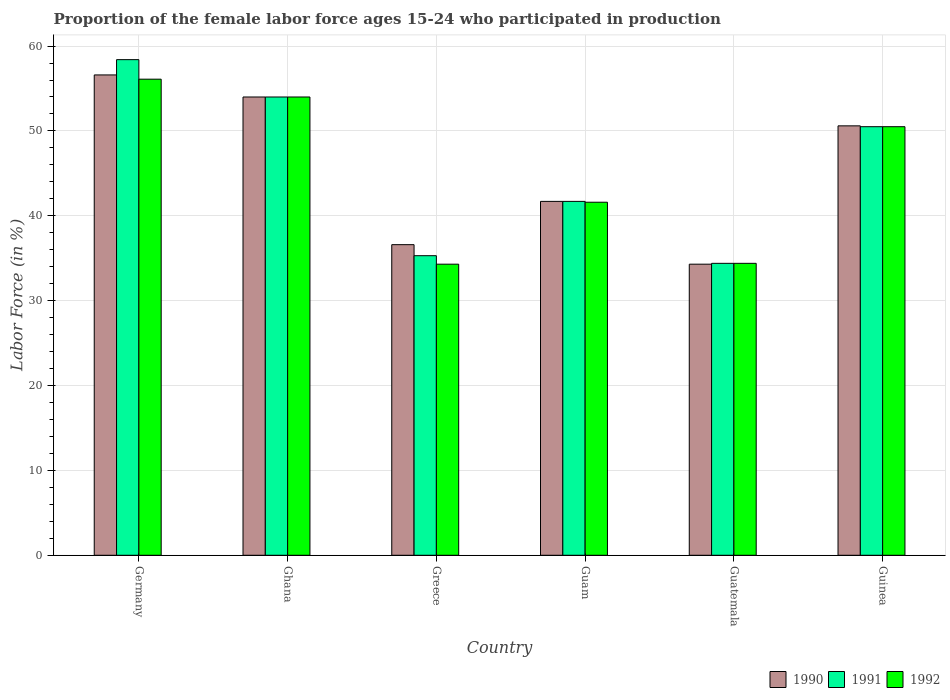Are the number of bars on each tick of the X-axis equal?
Your response must be concise. Yes. How many bars are there on the 6th tick from the right?
Your answer should be very brief. 3. In how many cases, is the number of bars for a given country not equal to the number of legend labels?
Your answer should be very brief. 0. What is the proportion of the female labor force who participated in production in 1990 in Germany?
Offer a very short reply. 56.6. Across all countries, what is the maximum proportion of the female labor force who participated in production in 1990?
Your answer should be compact. 56.6. Across all countries, what is the minimum proportion of the female labor force who participated in production in 1991?
Your response must be concise. 34.4. In which country was the proportion of the female labor force who participated in production in 1992 maximum?
Provide a short and direct response. Germany. In which country was the proportion of the female labor force who participated in production in 1992 minimum?
Your response must be concise. Greece. What is the total proportion of the female labor force who participated in production in 1990 in the graph?
Offer a terse response. 273.8. What is the difference between the proportion of the female labor force who participated in production in 1991 in Germany and that in Guam?
Your answer should be very brief. 16.7. What is the difference between the proportion of the female labor force who participated in production in 1990 in Greece and the proportion of the female labor force who participated in production in 1991 in Guinea?
Offer a very short reply. -13.9. What is the average proportion of the female labor force who participated in production in 1990 per country?
Offer a terse response. 45.63. What is the difference between the proportion of the female labor force who participated in production of/in 1991 and proportion of the female labor force who participated in production of/in 1990 in Guatemala?
Ensure brevity in your answer.  0.1. What is the ratio of the proportion of the female labor force who participated in production in 1992 in Ghana to that in Guinea?
Give a very brief answer. 1.07. Is the proportion of the female labor force who participated in production in 1991 in Ghana less than that in Greece?
Your response must be concise. No. Is the difference between the proportion of the female labor force who participated in production in 1991 in Guam and Guatemala greater than the difference between the proportion of the female labor force who participated in production in 1990 in Guam and Guatemala?
Your answer should be very brief. No. What is the difference between the highest and the second highest proportion of the female labor force who participated in production in 1991?
Offer a terse response. 7.9. What is the difference between the highest and the lowest proportion of the female labor force who participated in production in 1991?
Provide a short and direct response. 24. In how many countries, is the proportion of the female labor force who participated in production in 1990 greater than the average proportion of the female labor force who participated in production in 1990 taken over all countries?
Make the answer very short. 3. Is the sum of the proportion of the female labor force who participated in production in 1990 in Germany and Greece greater than the maximum proportion of the female labor force who participated in production in 1992 across all countries?
Your answer should be compact. Yes. What does the 2nd bar from the right in Guinea represents?
Your answer should be very brief. 1991. What is the difference between two consecutive major ticks on the Y-axis?
Provide a short and direct response. 10. Does the graph contain grids?
Ensure brevity in your answer.  Yes. How many legend labels are there?
Provide a short and direct response. 3. How are the legend labels stacked?
Offer a very short reply. Horizontal. What is the title of the graph?
Provide a short and direct response. Proportion of the female labor force ages 15-24 who participated in production. What is the label or title of the Y-axis?
Offer a very short reply. Labor Force (in %). What is the Labor Force (in %) of 1990 in Germany?
Provide a succinct answer. 56.6. What is the Labor Force (in %) of 1991 in Germany?
Provide a short and direct response. 58.4. What is the Labor Force (in %) in 1992 in Germany?
Provide a succinct answer. 56.1. What is the Labor Force (in %) of 1990 in Ghana?
Your answer should be compact. 54. What is the Labor Force (in %) in 1991 in Ghana?
Give a very brief answer. 54. What is the Labor Force (in %) in 1990 in Greece?
Your answer should be compact. 36.6. What is the Labor Force (in %) of 1991 in Greece?
Offer a terse response. 35.3. What is the Labor Force (in %) of 1992 in Greece?
Provide a short and direct response. 34.3. What is the Labor Force (in %) of 1990 in Guam?
Provide a succinct answer. 41.7. What is the Labor Force (in %) of 1991 in Guam?
Your answer should be compact. 41.7. What is the Labor Force (in %) of 1992 in Guam?
Your response must be concise. 41.6. What is the Labor Force (in %) in 1990 in Guatemala?
Offer a very short reply. 34.3. What is the Labor Force (in %) in 1991 in Guatemala?
Offer a terse response. 34.4. What is the Labor Force (in %) of 1992 in Guatemala?
Make the answer very short. 34.4. What is the Labor Force (in %) of 1990 in Guinea?
Make the answer very short. 50.6. What is the Labor Force (in %) in 1991 in Guinea?
Provide a succinct answer. 50.5. What is the Labor Force (in %) of 1992 in Guinea?
Provide a succinct answer. 50.5. Across all countries, what is the maximum Labor Force (in %) of 1990?
Provide a succinct answer. 56.6. Across all countries, what is the maximum Labor Force (in %) in 1991?
Give a very brief answer. 58.4. Across all countries, what is the maximum Labor Force (in %) of 1992?
Your answer should be very brief. 56.1. Across all countries, what is the minimum Labor Force (in %) of 1990?
Ensure brevity in your answer.  34.3. Across all countries, what is the minimum Labor Force (in %) of 1991?
Offer a very short reply. 34.4. Across all countries, what is the minimum Labor Force (in %) of 1992?
Offer a very short reply. 34.3. What is the total Labor Force (in %) of 1990 in the graph?
Provide a succinct answer. 273.8. What is the total Labor Force (in %) of 1991 in the graph?
Ensure brevity in your answer.  274.3. What is the total Labor Force (in %) of 1992 in the graph?
Make the answer very short. 270.9. What is the difference between the Labor Force (in %) in 1990 in Germany and that in Ghana?
Your response must be concise. 2.6. What is the difference between the Labor Force (in %) of 1992 in Germany and that in Ghana?
Keep it short and to the point. 2.1. What is the difference between the Labor Force (in %) of 1990 in Germany and that in Greece?
Your answer should be very brief. 20. What is the difference between the Labor Force (in %) of 1991 in Germany and that in Greece?
Provide a succinct answer. 23.1. What is the difference between the Labor Force (in %) of 1992 in Germany and that in Greece?
Provide a short and direct response. 21.8. What is the difference between the Labor Force (in %) in 1990 in Germany and that in Guam?
Your answer should be very brief. 14.9. What is the difference between the Labor Force (in %) of 1992 in Germany and that in Guam?
Keep it short and to the point. 14.5. What is the difference between the Labor Force (in %) of 1990 in Germany and that in Guatemala?
Make the answer very short. 22.3. What is the difference between the Labor Force (in %) in 1992 in Germany and that in Guatemala?
Your response must be concise. 21.7. What is the difference between the Labor Force (in %) in 1990 in Germany and that in Guinea?
Make the answer very short. 6. What is the difference between the Labor Force (in %) of 1990 in Ghana and that in Greece?
Make the answer very short. 17.4. What is the difference between the Labor Force (in %) in 1991 in Ghana and that in Greece?
Ensure brevity in your answer.  18.7. What is the difference between the Labor Force (in %) of 1990 in Ghana and that in Guam?
Offer a terse response. 12.3. What is the difference between the Labor Force (in %) of 1991 in Ghana and that in Guam?
Ensure brevity in your answer.  12.3. What is the difference between the Labor Force (in %) of 1990 in Ghana and that in Guatemala?
Give a very brief answer. 19.7. What is the difference between the Labor Force (in %) of 1991 in Ghana and that in Guatemala?
Ensure brevity in your answer.  19.6. What is the difference between the Labor Force (in %) of 1992 in Ghana and that in Guatemala?
Give a very brief answer. 19.6. What is the difference between the Labor Force (in %) of 1990 in Ghana and that in Guinea?
Provide a short and direct response. 3.4. What is the difference between the Labor Force (in %) in 1991 in Ghana and that in Guinea?
Provide a succinct answer. 3.5. What is the difference between the Labor Force (in %) in 1992 in Ghana and that in Guinea?
Your response must be concise. 3.5. What is the difference between the Labor Force (in %) of 1990 in Greece and that in Guam?
Keep it short and to the point. -5.1. What is the difference between the Labor Force (in %) in 1990 in Greece and that in Guatemala?
Your answer should be very brief. 2.3. What is the difference between the Labor Force (in %) of 1991 in Greece and that in Guatemala?
Ensure brevity in your answer.  0.9. What is the difference between the Labor Force (in %) of 1990 in Greece and that in Guinea?
Give a very brief answer. -14. What is the difference between the Labor Force (in %) in 1991 in Greece and that in Guinea?
Offer a very short reply. -15.2. What is the difference between the Labor Force (in %) in 1992 in Greece and that in Guinea?
Give a very brief answer. -16.2. What is the difference between the Labor Force (in %) in 1991 in Guam and that in Guatemala?
Provide a short and direct response. 7.3. What is the difference between the Labor Force (in %) in 1992 in Guam and that in Guatemala?
Your answer should be compact. 7.2. What is the difference between the Labor Force (in %) of 1990 in Guam and that in Guinea?
Keep it short and to the point. -8.9. What is the difference between the Labor Force (in %) of 1991 in Guam and that in Guinea?
Your response must be concise. -8.8. What is the difference between the Labor Force (in %) in 1992 in Guam and that in Guinea?
Give a very brief answer. -8.9. What is the difference between the Labor Force (in %) in 1990 in Guatemala and that in Guinea?
Ensure brevity in your answer.  -16.3. What is the difference between the Labor Force (in %) of 1991 in Guatemala and that in Guinea?
Keep it short and to the point. -16.1. What is the difference between the Labor Force (in %) of 1992 in Guatemala and that in Guinea?
Keep it short and to the point. -16.1. What is the difference between the Labor Force (in %) of 1990 in Germany and the Labor Force (in %) of 1991 in Ghana?
Keep it short and to the point. 2.6. What is the difference between the Labor Force (in %) of 1990 in Germany and the Labor Force (in %) of 1992 in Ghana?
Offer a terse response. 2.6. What is the difference between the Labor Force (in %) of 1990 in Germany and the Labor Force (in %) of 1991 in Greece?
Offer a terse response. 21.3. What is the difference between the Labor Force (in %) of 1990 in Germany and the Labor Force (in %) of 1992 in Greece?
Make the answer very short. 22.3. What is the difference between the Labor Force (in %) of 1991 in Germany and the Labor Force (in %) of 1992 in Greece?
Your response must be concise. 24.1. What is the difference between the Labor Force (in %) in 1990 in Germany and the Labor Force (in %) in 1991 in Guam?
Your answer should be very brief. 14.9. What is the difference between the Labor Force (in %) of 1991 in Germany and the Labor Force (in %) of 1992 in Guam?
Make the answer very short. 16.8. What is the difference between the Labor Force (in %) of 1991 in Germany and the Labor Force (in %) of 1992 in Guatemala?
Keep it short and to the point. 24. What is the difference between the Labor Force (in %) of 1990 in Germany and the Labor Force (in %) of 1992 in Guinea?
Offer a terse response. 6.1. What is the difference between the Labor Force (in %) in 1991 in Ghana and the Labor Force (in %) in 1992 in Guam?
Offer a terse response. 12.4. What is the difference between the Labor Force (in %) in 1990 in Ghana and the Labor Force (in %) in 1991 in Guatemala?
Provide a succinct answer. 19.6. What is the difference between the Labor Force (in %) in 1990 in Ghana and the Labor Force (in %) in 1992 in Guatemala?
Ensure brevity in your answer.  19.6. What is the difference between the Labor Force (in %) in 1991 in Ghana and the Labor Force (in %) in 1992 in Guatemala?
Your response must be concise. 19.6. What is the difference between the Labor Force (in %) in 1990 in Ghana and the Labor Force (in %) in 1991 in Guinea?
Your answer should be compact. 3.5. What is the difference between the Labor Force (in %) in 1990 in Ghana and the Labor Force (in %) in 1992 in Guinea?
Provide a succinct answer. 3.5. What is the difference between the Labor Force (in %) in 1991 in Ghana and the Labor Force (in %) in 1992 in Guinea?
Your answer should be very brief. 3.5. What is the difference between the Labor Force (in %) in 1990 in Greece and the Labor Force (in %) in 1991 in Guam?
Provide a succinct answer. -5.1. What is the difference between the Labor Force (in %) in 1990 in Greece and the Labor Force (in %) in 1992 in Guam?
Your answer should be very brief. -5. What is the difference between the Labor Force (in %) in 1990 in Greece and the Labor Force (in %) in 1991 in Guatemala?
Your answer should be compact. 2.2. What is the difference between the Labor Force (in %) in 1991 in Greece and the Labor Force (in %) in 1992 in Guatemala?
Keep it short and to the point. 0.9. What is the difference between the Labor Force (in %) of 1991 in Greece and the Labor Force (in %) of 1992 in Guinea?
Keep it short and to the point. -15.2. What is the difference between the Labor Force (in %) of 1990 in Guam and the Labor Force (in %) of 1992 in Guatemala?
Provide a short and direct response. 7.3. What is the difference between the Labor Force (in %) in 1991 in Guam and the Labor Force (in %) in 1992 in Guatemala?
Offer a very short reply. 7.3. What is the difference between the Labor Force (in %) in 1990 in Guatemala and the Labor Force (in %) in 1991 in Guinea?
Your response must be concise. -16.2. What is the difference between the Labor Force (in %) in 1990 in Guatemala and the Labor Force (in %) in 1992 in Guinea?
Provide a short and direct response. -16.2. What is the difference between the Labor Force (in %) of 1991 in Guatemala and the Labor Force (in %) of 1992 in Guinea?
Keep it short and to the point. -16.1. What is the average Labor Force (in %) of 1990 per country?
Your response must be concise. 45.63. What is the average Labor Force (in %) of 1991 per country?
Offer a terse response. 45.72. What is the average Labor Force (in %) of 1992 per country?
Ensure brevity in your answer.  45.15. What is the difference between the Labor Force (in %) of 1990 and Labor Force (in %) of 1991 in Germany?
Ensure brevity in your answer.  -1.8. What is the difference between the Labor Force (in %) of 1990 and Labor Force (in %) of 1992 in Germany?
Your response must be concise. 0.5. What is the difference between the Labor Force (in %) in 1990 and Labor Force (in %) in 1992 in Ghana?
Provide a short and direct response. 0. What is the difference between the Labor Force (in %) in 1991 and Labor Force (in %) in 1992 in Ghana?
Your answer should be compact. 0. What is the difference between the Labor Force (in %) in 1990 and Labor Force (in %) in 1991 in Greece?
Keep it short and to the point. 1.3. What is the difference between the Labor Force (in %) in 1990 and Labor Force (in %) in 1992 in Greece?
Provide a succinct answer. 2.3. What is the difference between the Labor Force (in %) of 1990 and Labor Force (in %) of 1991 in Guam?
Your response must be concise. 0. What is the difference between the Labor Force (in %) in 1990 and Labor Force (in %) in 1991 in Guatemala?
Offer a terse response. -0.1. What is the difference between the Labor Force (in %) in 1990 and Labor Force (in %) in 1992 in Guatemala?
Give a very brief answer. -0.1. What is the difference between the Labor Force (in %) in 1991 and Labor Force (in %) in 1992 in Guatemala?
Your answer should be very brief. 0. What is the ratio of the Labor Force (in %) of 1990 in Germany to that in Ghana?
Your response must be concise. 1.05. What is the ratio of the Labor Force (in %) in 1991 in Germany to that in Ghana?
Your response must be concise. 1.08. What is the ratio of the Labor Force (in %) in 1992 in Germany to that in Ghana?
Ensure brevity in your answer.  1.04. What is the ratio of the Labor Force (in %) in 1990 in Germany to that in Greece?
Give a very brief answer. 1.55. What is the ratio of the Labor Force (in %) in 1991 in Germany to that in Greece?
Keep it short and to the point. 1.65. What is the ratio of the Labor Force (in %) in 1992 in Germany to that in Greece?
Offer a terse response. 1.64. What is the ratio of the Labor Force (in %) in 1990 in Germany to that in Guam?
Give a very brief answer. 1.36. What is the ratio of the Labor Force (in %) in 1991 in Germany to that in Guam?
Provide a succinct answer. 1.4. What is the ratio of the Labor Force (in %) of 1992 in Germany to that in Guam?
Offer a terse response. 1.35. What is the ratio of the Labor Force (in %) in 1990 in Germany to that in Guatemala?
Provide a short and direct response. 1.65. What is the ratio of the Labor Force (in %) in 1991 in Germany to that in Guatemala?
Your answer should be very brief. 1.7. What is the ratio of the Labor Force (in %) in 1992 in Germany to that in Guatemala?
Make the answer very short. 1.63. What is the ratio of the Labor Force (in %) in 1990 in Germany to that in Guinea?
Give a very brief answer. 1.12. What is the ratio of the Labor Force (in %) of 1991 in Germany to that in Guinea?
Your answer should be very brief. 1.16. What is the ratio of the Labor Force (in %) of 1992 in Germany to that in Guinea?
Make the answer very short. 1.11. What is the ratio of the Labor Force (in %) in 1990 in Ghana to that in Greece?
Offer a terse response. 1.48. What is the ratio of the Labor Force (in %) of 1991 in Ghana to that in Greece?
Ensure brevity in your answer.  1.53. What is the ratio of the Labor Force (in %) of 1992 in Ghana to that in Greece?
Provide a succinct answer. 1.57. What is the ratio of the Labor Force (in %) in 1990 in Ghana to that in Guam?
Offer a terse response. 1.29. What is the ratio of the Labor Force (in %) of 1991 in Ghana to that in Guam?
Give a very brief answer. 1.29. What is the ratio of the Labor Force (in %) in 1992 in Ghana to that in Guam?
Give a very brief answer. 1.3. What is the ratio of the Labor Force (in %) of 1990 in Ghana to that in Guatemala?
Make the answer very short. 1.57. What is the ratio of the Labor Force (in %) of 1991 in Ghana to that in Guatemala?
Provide a succinct answer. 1.57. What is the ratio of the Labor Force (in %) in 1992 in Ghana to that in Guatemala?
Provide a succinct answer. 1.57. What is the ratio of the Labor Force (in %) in 1990 in Ghana to that in Guinea?
Keep it short and to the point. 1.07. What is the ratio of the Labor Force (in %) of 1991 in Ghana to that in Guinea?
Ensure brevity in your answer.  1.07. What is the ratio of the Labor Force (in %) of 1992 in Ghana to that in Guinea?
Make the answer very short. 1.07. What is the ratio of the Labor Force (in %) of 1990 in Greece to that in Guam?
Give a very brief answer. 0.88. What is the ratio of the Labor Force (in %) in 1991 in Greece to that in Guam?
Your answer should be very brief. 0.85. What is the ratio of the Labor Force (in %) of 1992 in Greece to that in Guam?
Make the answer very short. 0.82. What is the ratio of the Labor Force (in %) of 1990 in Greece to that in Guatemala?
Offer a very short reply. 1.07. What is the ratio of the Labor Force (in %) of 1991 in Greece to that in Guatemala?
Give a very brief answer. 1.03. What is the ratio of the Labor Force (in %) of 1990 in Greece to that in Guinea?
Provide a short and direct response. 0.72. What is the ratio of the Labor Force (in %) in 1991 in Greece to that in Guinea?
Your answer should be very brief. 0.7. What is the ratio of the Labor Force (in %) of 1992 in Greece to that in Guinea?
Keep it short and to the point. 0.68. What is the ratio of the Labor Force (in %) of 1990 in Guam to that in Guatemala?
Provide a succinct answer. 1.22. What is the ratio of the Labor Force (in %) of 1991 in Guam to that in Guatemala?
Provide a succinct answer. 1.21. What is the ratio of the Labor Force (in %) of 1992 in Guam to that in Guatemala?
Offer a very short reply. 1.21. What is the ratio of the Labor Force (in %) of 1990 in Guam to that in Guinea?
Keep it short and to the point. 0.82. What is the ratio of the Labor Force (in %) of 1991 in Guam to that in Guinea?
Your response must be concise. 0.83. What is the ratio of the Labor Force (in %) of 1992 in Guam to that in Guinea?
Provide a short and direct response. 0.82. What is the ratio of the Labor Force (in %) in 1990 in Guatemala to that in Guinea?
Your answer should be compact. 0.68. What is the ratio of the Labor Force (in %) in 1991 in Guatemala to that in Guinea?
Offer a terse response. 0.68. What is the ratio of the Labor Force (in %) in 1992 in Guatemala to that in Guinea?
Your response must be concise. 0.68. What is the difference between the highest and the second highest Labor Force (in %) in 1990?
Offer a very short reply. 2.6. What is the difference between the highest and the lowest Labor Force (in %) of 1990?
Offer a very short reply. 22.3. What is the difference between the highest and the lowest Labor Force (in %) of 1992?
Keep it short and to the point. 21.8. 